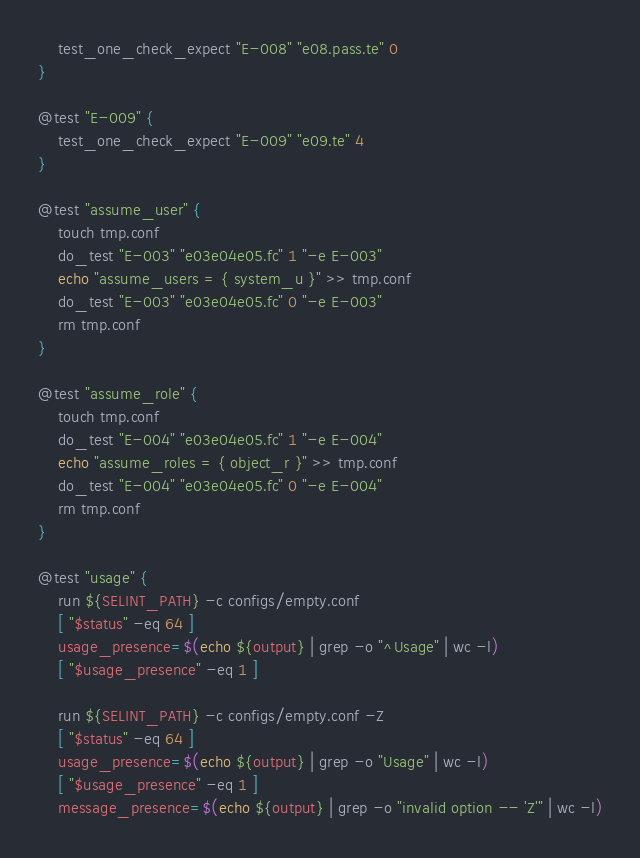Convert code to text. <code><loc_0><loc_0><loc_500><loc_500><_Bash_>	test_one_check_expect "E-008" "e08.pass.te" 0
}

@test "E-009" {
	test_one_check_expect "E-009" "e09.te" 4
}

@test "assume_user" {
	touch tmp.conf
	do_test "E-003" "e03e04e05.fc" 1 "-e E-003"
	echo "assume_users = { system_u }" >> tmp.conf
	do_test "E-003" "e03e04e05.fc" 0 "-e E-003"
	rm tmp.conf
}

@test "assume_role" {
	touch tmp.conf
	do_test "E-004" "e03e04e05.fc" 1 "-e E-004"
	echo "assume_roles = { object_r }" >> tmp.conf
	do_test "E-004" "e03e04e05.fc" 0 "-e E-004"
	rm tmp.conf
}

@test "usage" {
	run ${SELINT_PATH} -c configs/empty.conf
	[ "$status" -eq 64 ]
	usage_presence=$(echo ${output} | grep -o "^Usage" | wc -l)
	[ "$usage_presence" -eq 1 ]

	run ${SELINT_PATH} -c configs/empty.conf -Z
	[ "$status" -eq 64 ]
	usage_presence=$(echo ${output} | grep -o "Usage" | wc -l)
	[ "$usage_presence" -eq 1 ]
	message_presence=$(echo ${output} | grep -o "invalid option -- 'Z'" | wc -l)</code> 